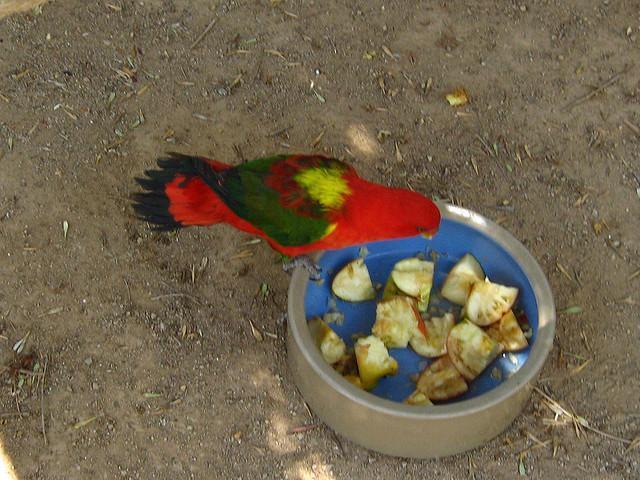How many apples are in the photo?
Give a very brief answer. 2. 